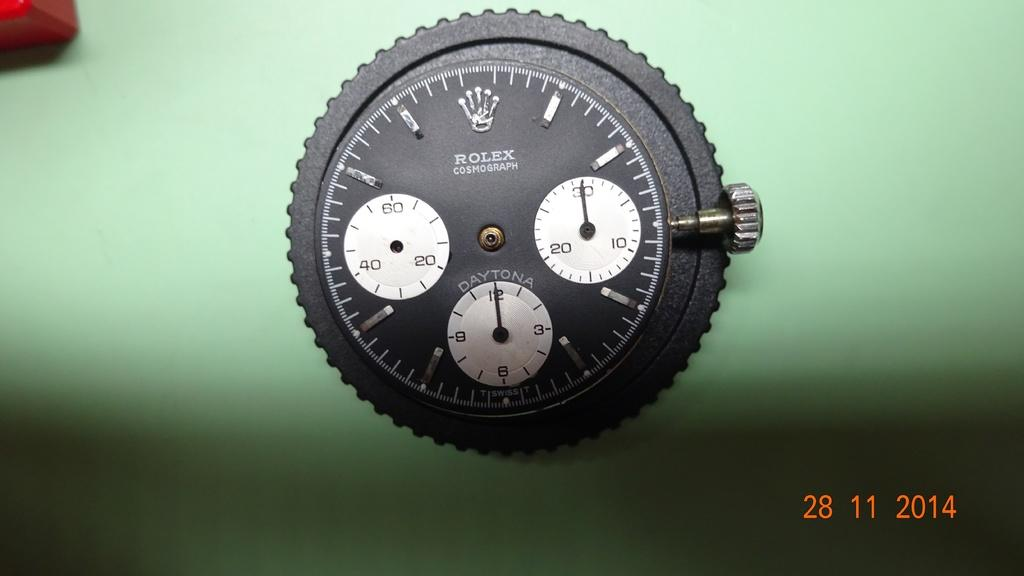<image>
Describe the image concisely. A black Rolex watch face sits on a green background. 